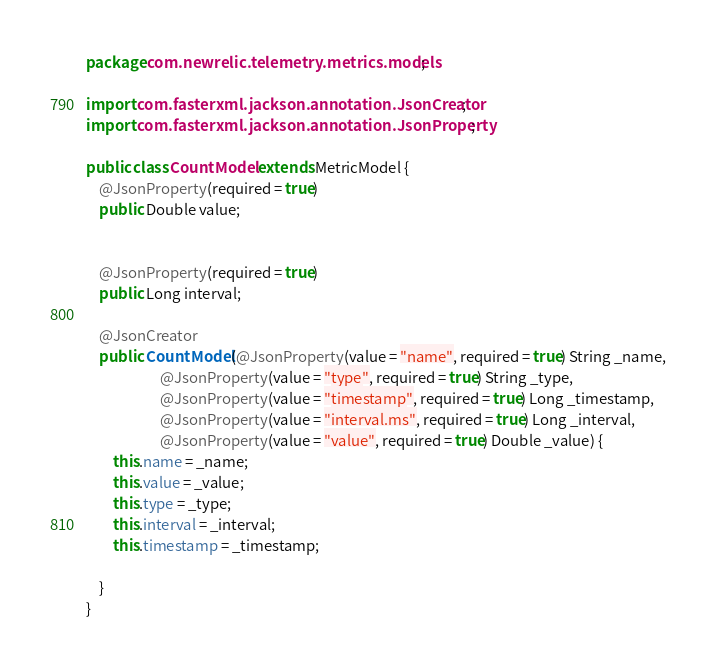Convert code to text. <code><loc_0><loc_0><loc_500><loc_500><_Java_>package com.newrelic.telemetry.metrics.models;

import com.fasterxml.jackson.annotation.JsonCreator;
import com.fasterxml.jackson.annotation.JsonProperty;

public class CountModel extends MetricModel {
    @JsonProperty(required = true)
    public Double value;


    @JsonProperty(required = true)
    public Long interval;

    @JsonCreator
    public CountModel(@JsonProperty(value = "name", required = true) String _name,
                      @JsonProperty(value = "type", required = true) String _type,
                      @JsonProperty(value = "timestamp", required = true) Long _timestamp,
                      @JsonProperty(value = "interval.ms", required = true) Long _interval,
                      @JsonProperty(value = "value", required = true) Double _value) {
        this.name = _name;
        this.value = _value;
        this.type = _type;
        this.interval = _interval;
        this.timestamp = _timestamp;

    }
}
</code> 